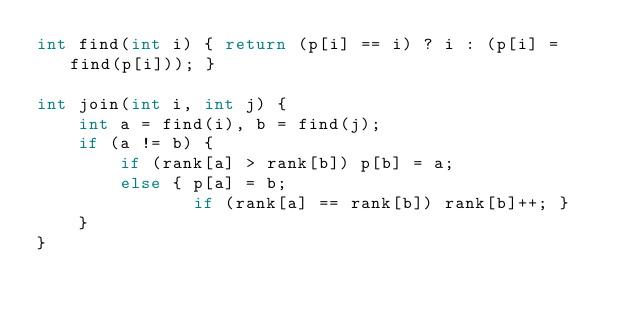<code> <loc_0><loc_0><loc_500><loc_500><_C++_>int find(int i) { return (p[i] == i) ? i : (p[i] = find(p[i])); }

int join(int i, int j) {
	int a = find(i), b = find(j);
	if (a != b) {
		if (rank[a] > rank[b]) p[b] = a;
		else { p[a] = b;
			   if (rank[a] == rank[b]) rank[b]++; }
	}
}</code> 